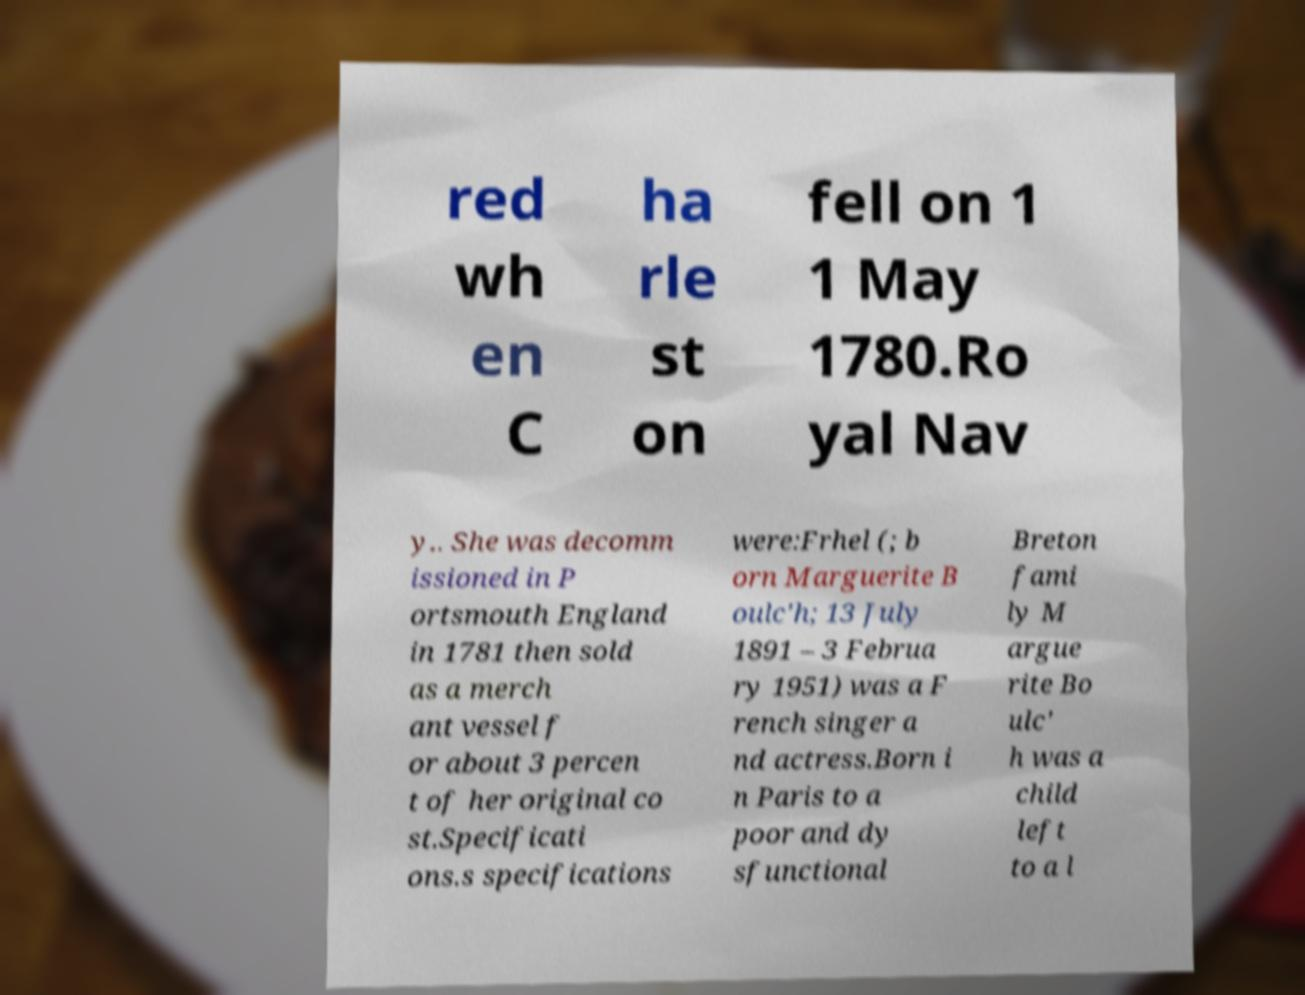Please identify and transcribe the text found in this image. red wh en C ha rle st on fell on 1 1 May 1780.Ro yal Nav y.. She was decomm issioned in P ortsmouth England in 1781 then sold as a merch ant vessel f or about 3 percen t of her original co st.Specificati ons.s specifications were:Frhel (; b orn Marguerite B oulc'h; 13 July 1891 – 3 Februa ry 1951) was a F rench singer a nd actress.Born i n Paris to a poor and dy sfunctional Breton fami ly M argue rite Bo ulc' h was a child left to a l 